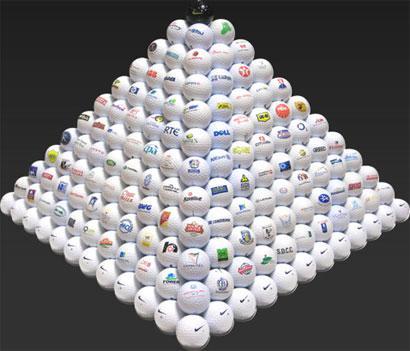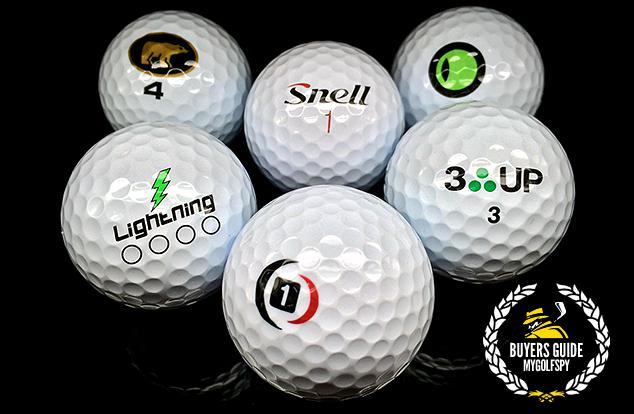The first image is the image on the left, the second image is the image on the right. For the images shown, is this caption "Exactly four balls are posed close together in one image, and all balls have the same surface color." true? Answer yes or no. No. The first image is the image on the left, the second image is the image on the right. Given the left and right images, does the statement "At least one of the images feature a six golf balls arranged in a shape." hold true? Answer yes or no. Yes. 